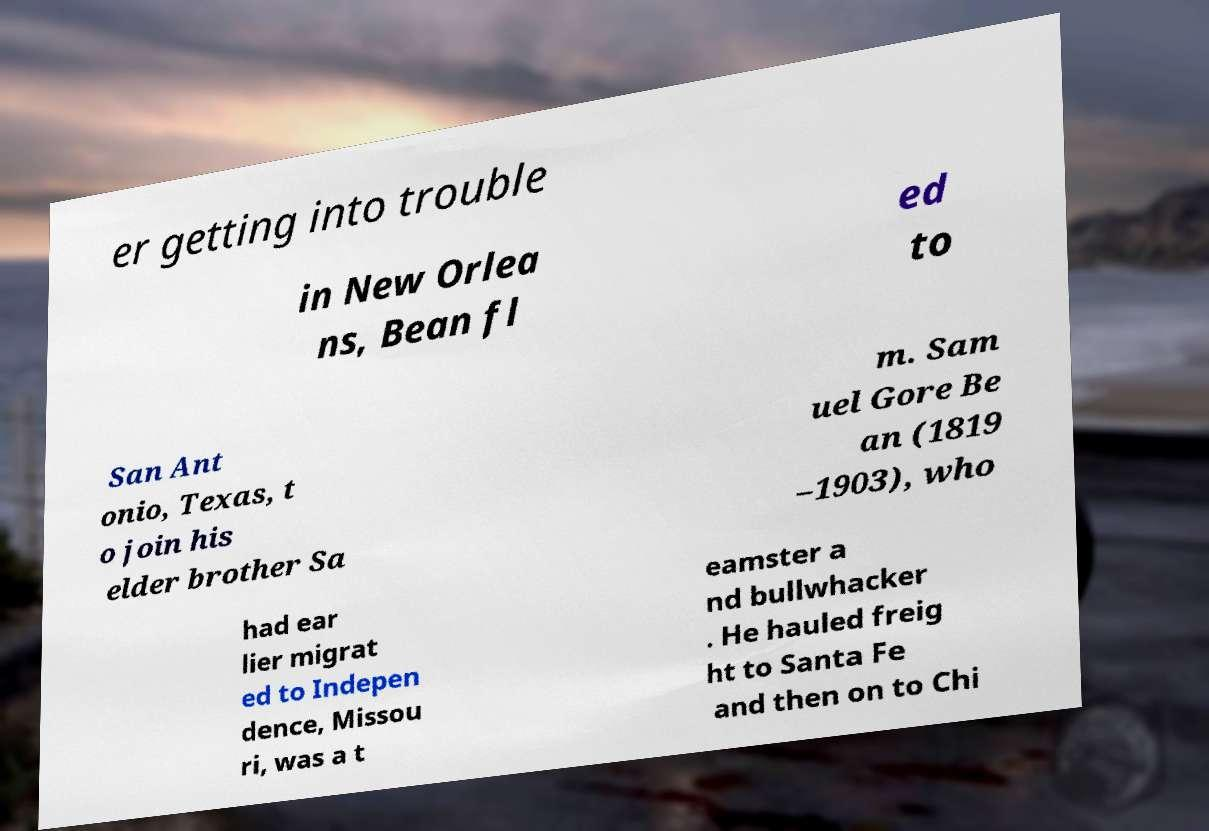Can you read and provide the text displayed in the image?This photo seems to have some interesting text. Can you extract and type it out for me? er getting into trouble in New Orlea ns, Bean fl ed to San Ant onio, Texas, t o join his elder brother Sa m. Sam uel Gore Be an (1819 –1903), who had ear lier migrat ed to Indepen dence, Missou ri, was a t eamster a nd bullwhacker . He hauled freig ht to Santa Fe and then on to Chi 